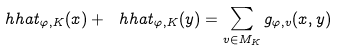Convert formula to latex. <formula><loc_0><loc_0><loc_500><loc_500>\ h h a t _ { \varphi , K } ( x ) + \ h h a t _ { \varphi , K } ( y ) = \sum _ { v \in M _ { K } } g _ { \varphi , v } ( x , y )</formula> 